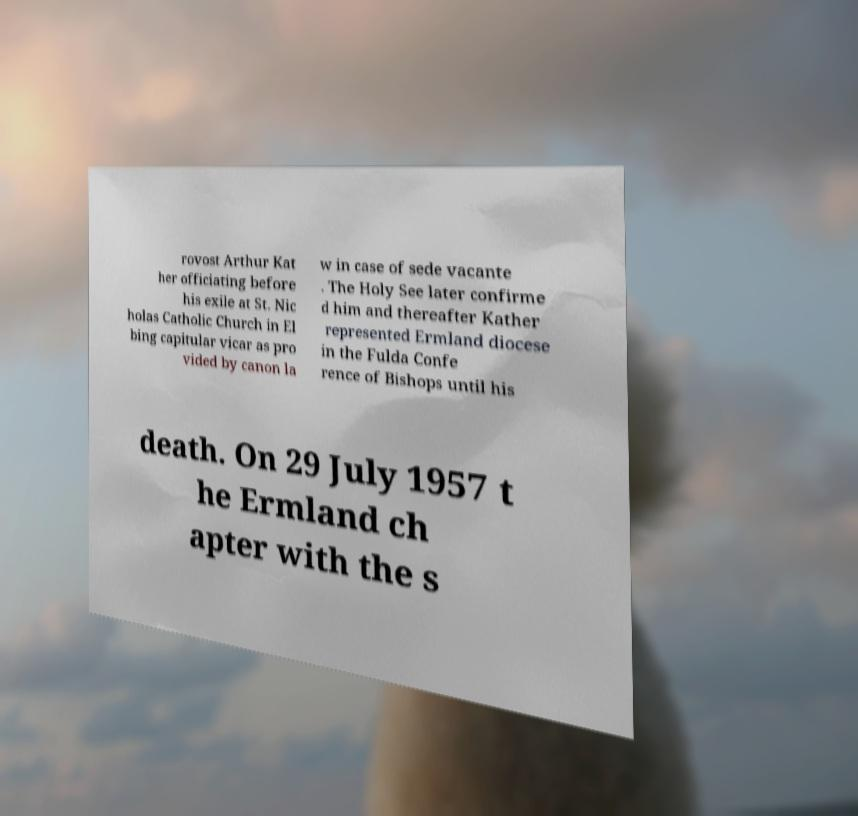I need the written content from this picture converted into text. Can you do that? rovost Arthur Kat her officiating before his exile at St. Nic holas Catholic Church in El bing capitular vicar as pro vided by canon la w in case of sede vacante . The Holy See later confirme d him and thereafter Kather represented Ermland diocese in the Fulda Confe rence of Bishops until his death. On 29 July 1957 t he Ermland ch apter with the s 